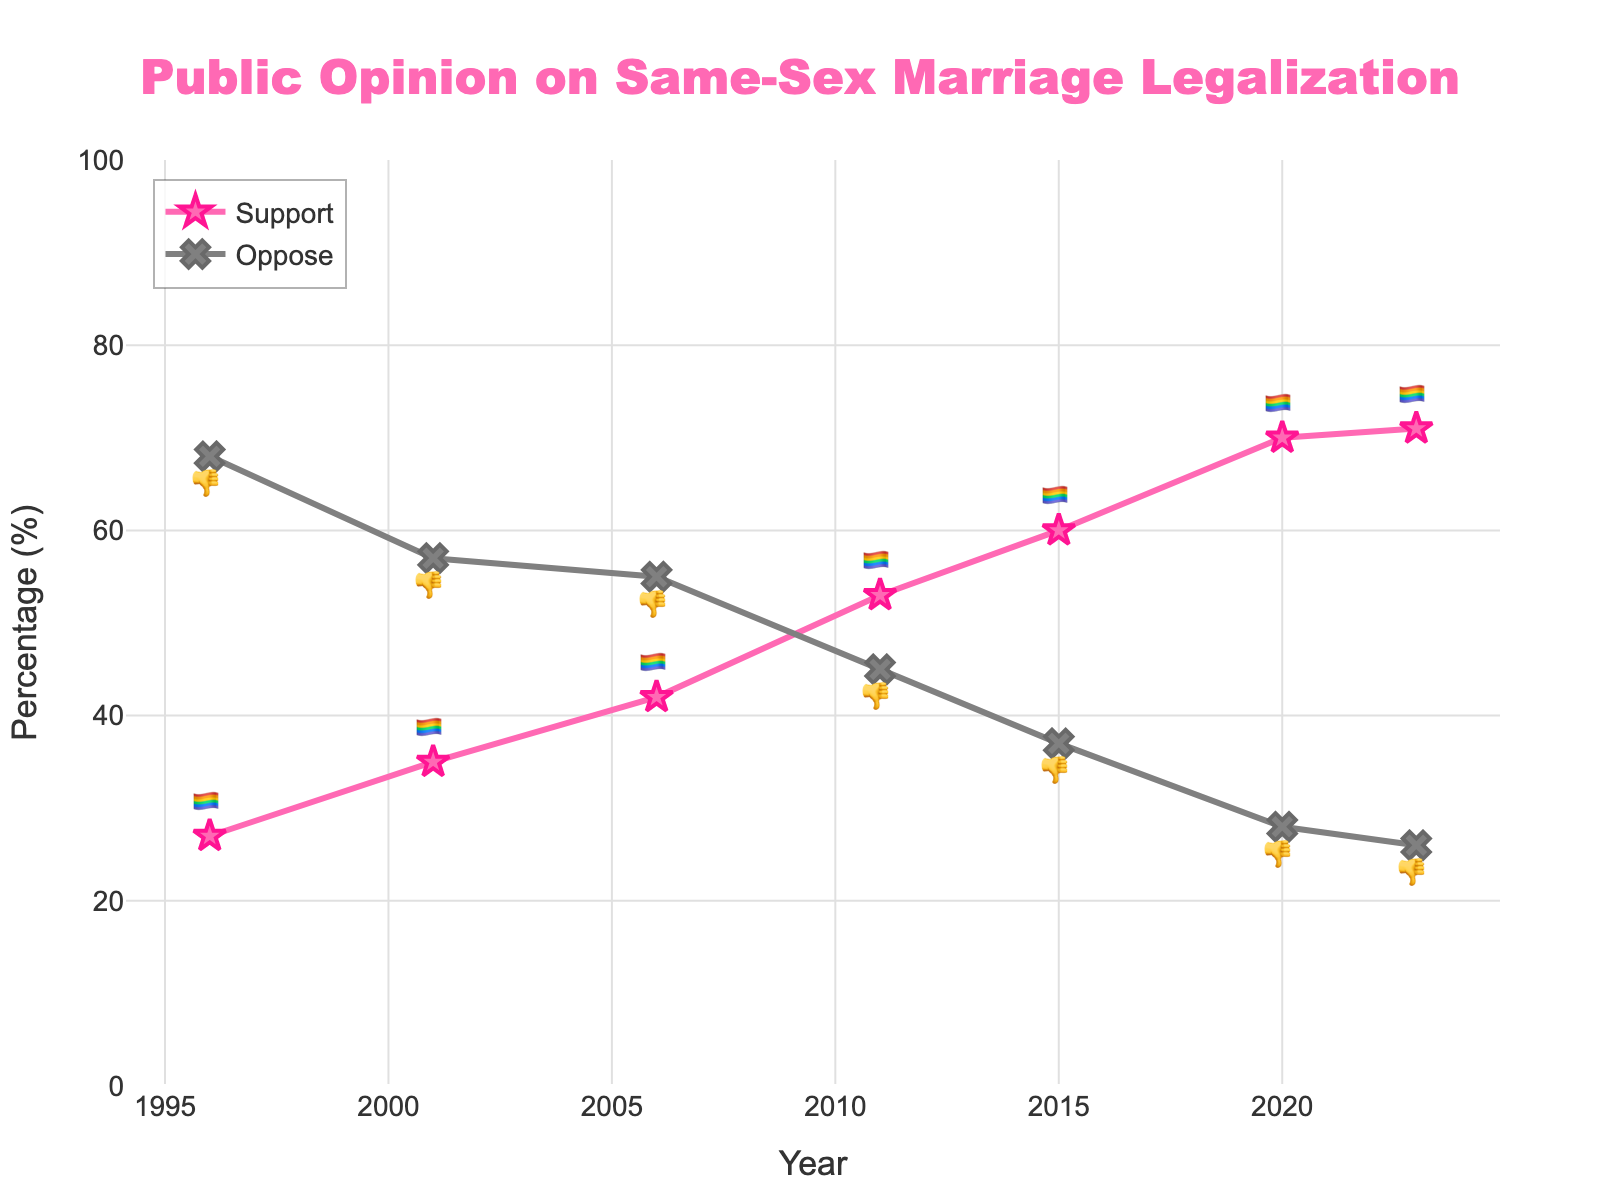What is the title of the chart? The title of the chart is prominently displayed at the top.
Answer: Public Opinion on Same-Sex Marriage Legalization How many data points are there on the chart? Count the number of markers for each line.
Answer: 7 What does the pink line represent? The legend and the labels on the pink line indicate what it represents.
Answer: Support What year did support for same-sex marriage first exceed opposition? Identify the year where the pink line (support) crosses above the grey line (oppose).
Answer: 2011 How much did support for same-sex marriage increase between 1996 and 2023? Subtract the support percentage in 1996 from the support percentage in 2023.
Answer: 44% Which year had the highest opposition to same-sex marriage? Locate the peak of the grey line.
Answer: 1996 Compare the support and opposition percentages in 2001. Which one was greater and by how much? Find the values for both support and opposition in 2001 and subtract the smaller from the larger to know the difference.
Answer: Opposition was greater by 22% By how many percentage points did support for same-sex marriage change from 2015 to 2020? Subtract the support percentage in 2015 from the support percentage in 2020.
Answer: 10% What is the most recent year shown in the chart, and what are the support and opposition percentages for that year? Look at the final data point on each line and note the year along with the values for both percentages.
Answer: 2023, Support: 71%, Opposition: 26% Which year marks a 50%-plus support for same-sex marriage and what is the emoji used for representing it? Identify the year where the support percentage first exceeds 50% and note the emoji used on that marker.
Answer: 2011, 🏳️‍🌈 